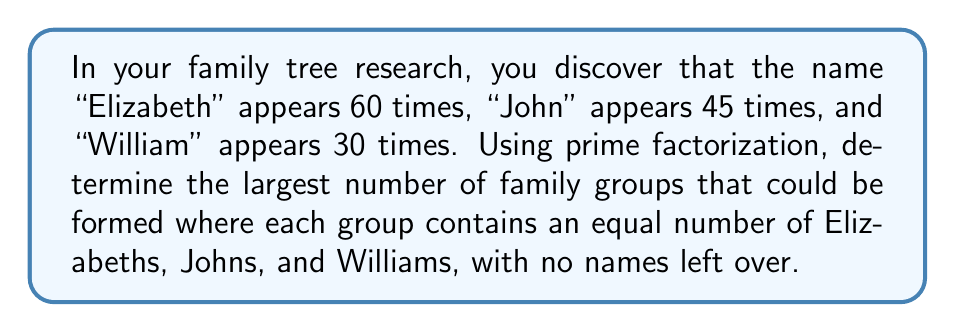Could you help me with this problem? To solve this problem, we need to follow these steps:

1. Find the prime factorization of each name's frequency:
   Elizabeth: $60 = 2^2 \times 3 \times 5$
   John: $45 = 3^2 \times 5$
   William: $30 = 2 \times 3 \times 5$

2. To ensure each group has an equal number of each name with no names left over, we need to find the greatest common divisor (GCD) of these three numbers.

3. The GCD will be the product of the common prime factors with the lowest exponent in each factorization:
   
   Common factors:
   - $3$ appears in all three (lowest exponent is 1)
   - $5$ appears in all three (exponent is always 1)

4. Therefore, the GCD is:
   $GCD = 3 \times 5 = 15$

5. This means we can form 15 family groups, each containing:
   - Elizabeth: $60 \div 15 = 4$ members
   - John: $45 \div 15 = 3$ members
   - William: $30 \div 15 = 2$ members

Thus, the largest number of family groups that can be formed with an equal distribution of these names is 15.
Answer: 15 family groups 